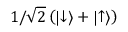Convert formula to latex. <formula><loc_0><loc_0><loc_500><loc_500>1 / \sqrt { 2 } \left ( | { \downarrow } \rangle + | { \uparrow } \rangle \right )</formula> 